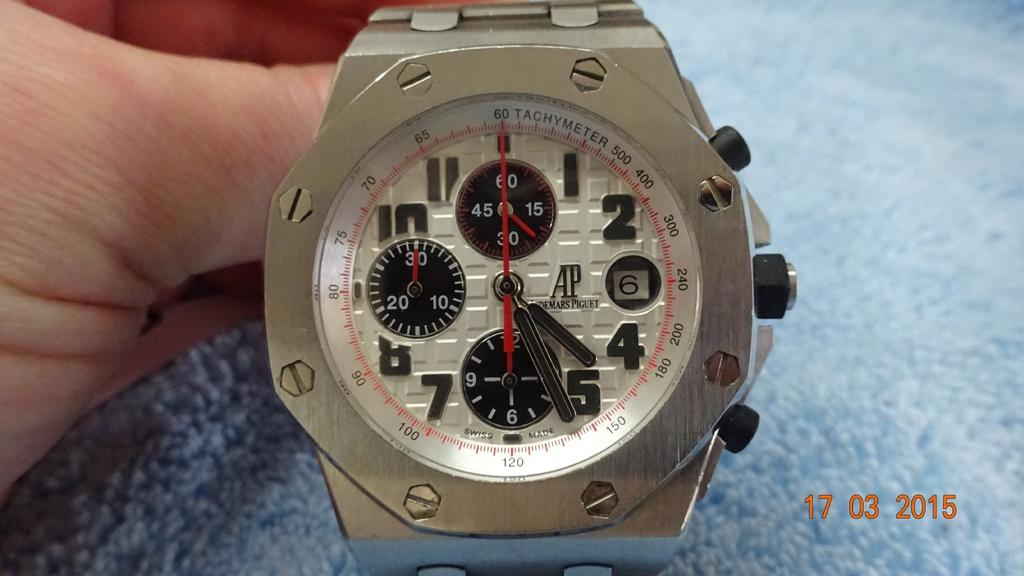<image>
Offer a succinct explanation of the picture presented. A heavy duty looking metal watch with a Tachymeter. 